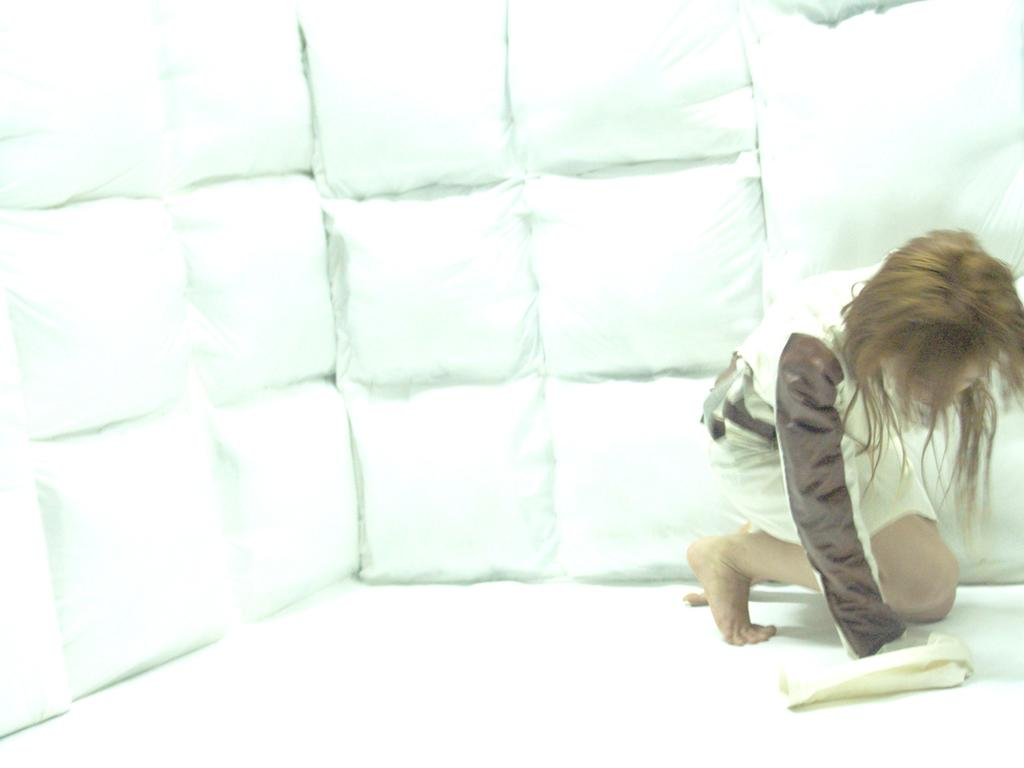Where is the person located in the image? The person is sitting in the bottom right corner of the image. What is the person holding in the image? The person is holding a cloth. Can you describe the cloth that is visible behind the person? There is a cloth visible behind the person. What type of beds can be seen in the image? There are no beds present in the image. 